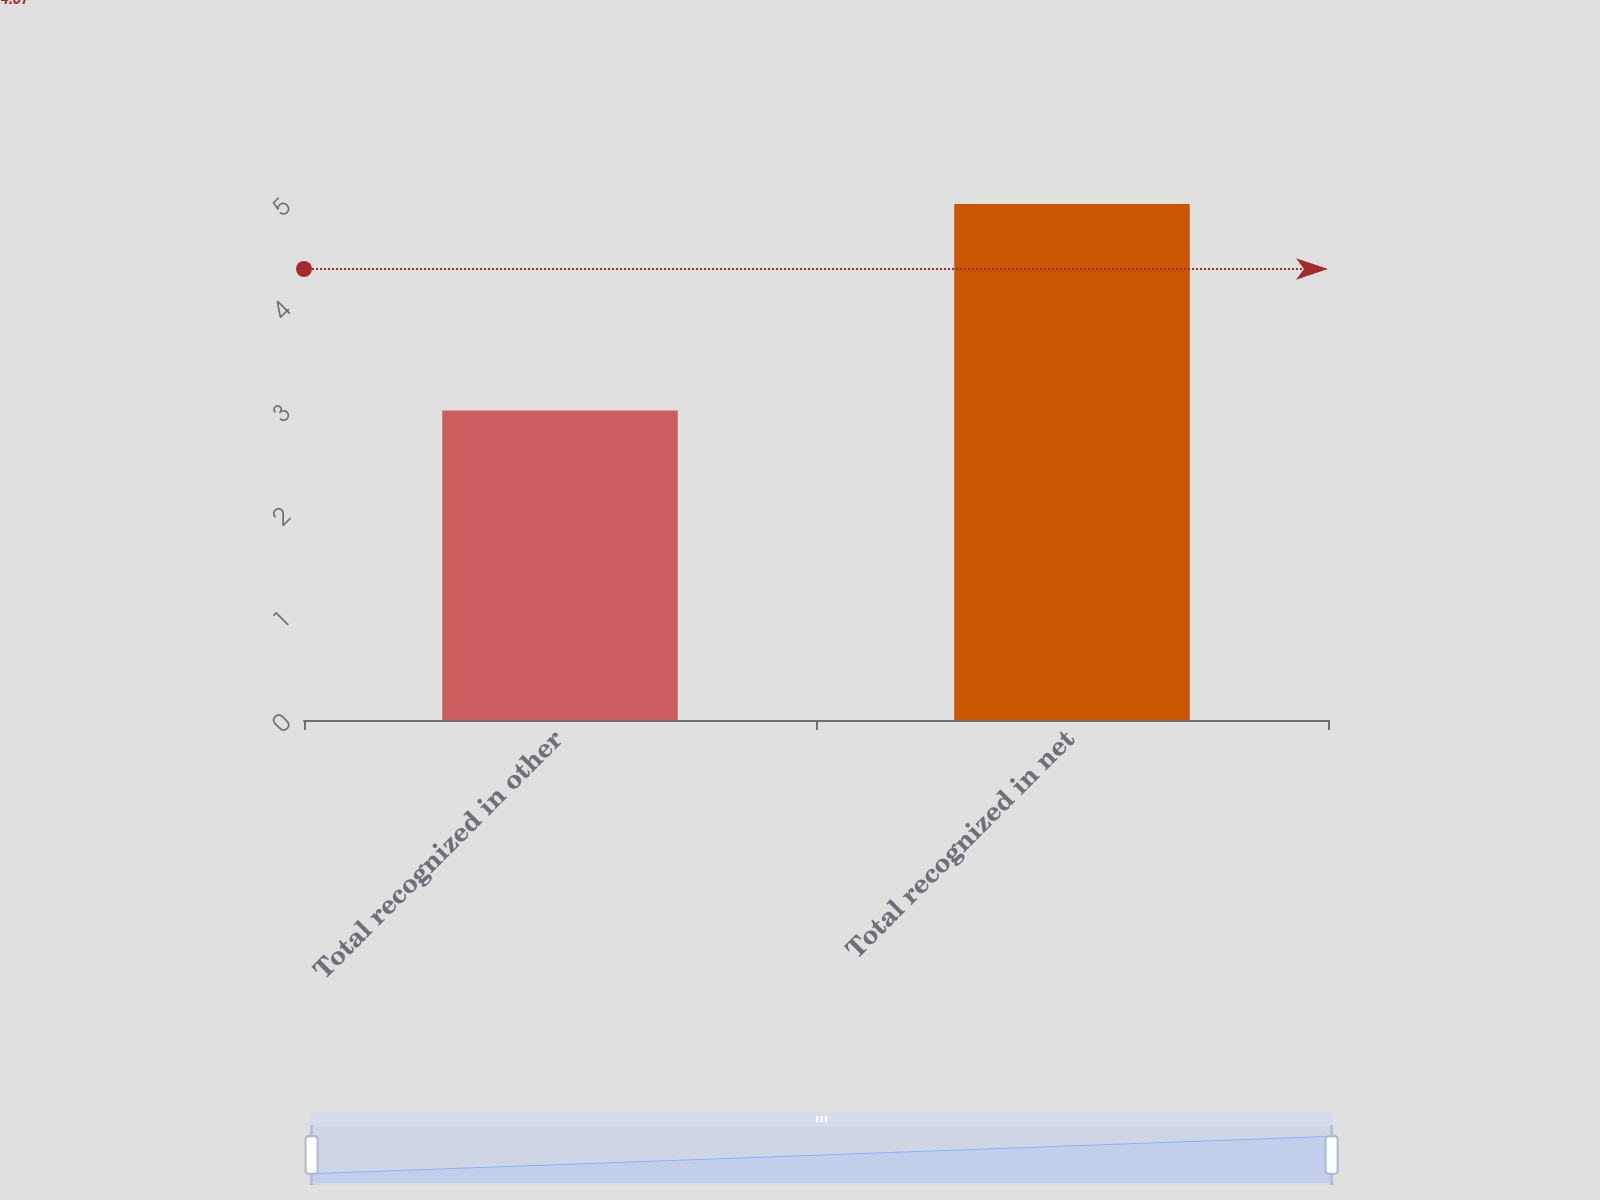Convert chart to OTSL. <chart><loc_0><loc_0><loc_500><loc_500><bar_chart><fcel>Total recognized in other<fcel>Total recognized in net<nl><fcel>3<fcel>5<nl></chart> 